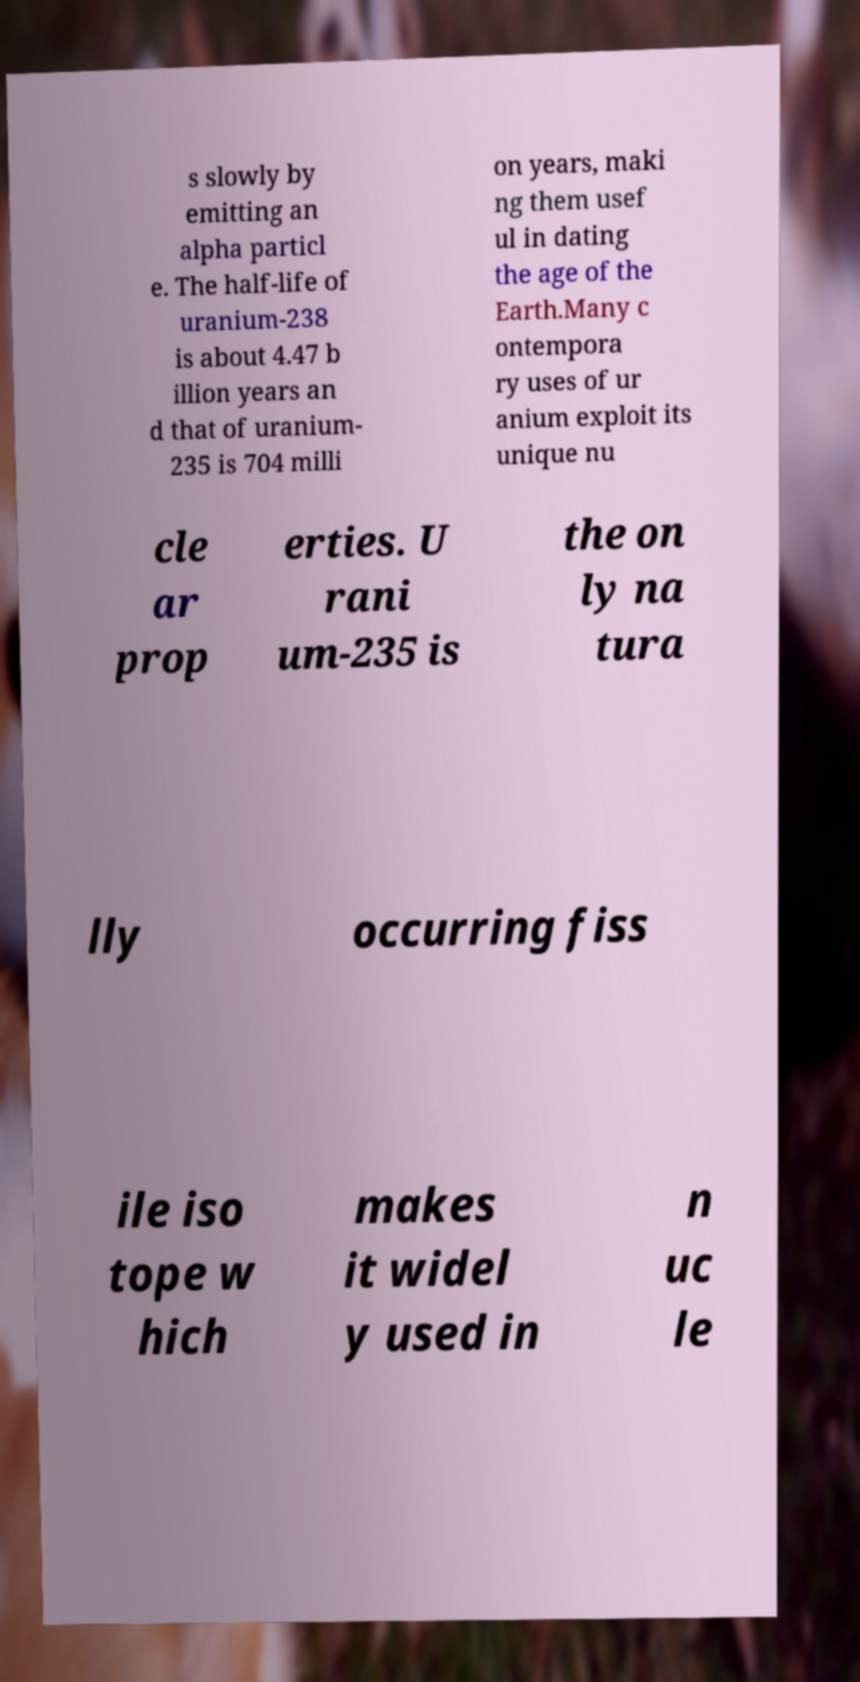I need the written content from this picture converted into text. Can you do that? s slowly by emitting an alpha particl e. The half-life of uranium-238 is about 4.47 b illion years an d that of uranium- 235 is 704 milli on years, maki ng them usef ul in dating the age of the Earth.Many c ontempora ry uses of ur anium exploit its unique nu cle ar prop erties. U rani um-235 is the on ly na tura lly occurring fiss ile iso tope w hich makes it widel y used in n uc le 